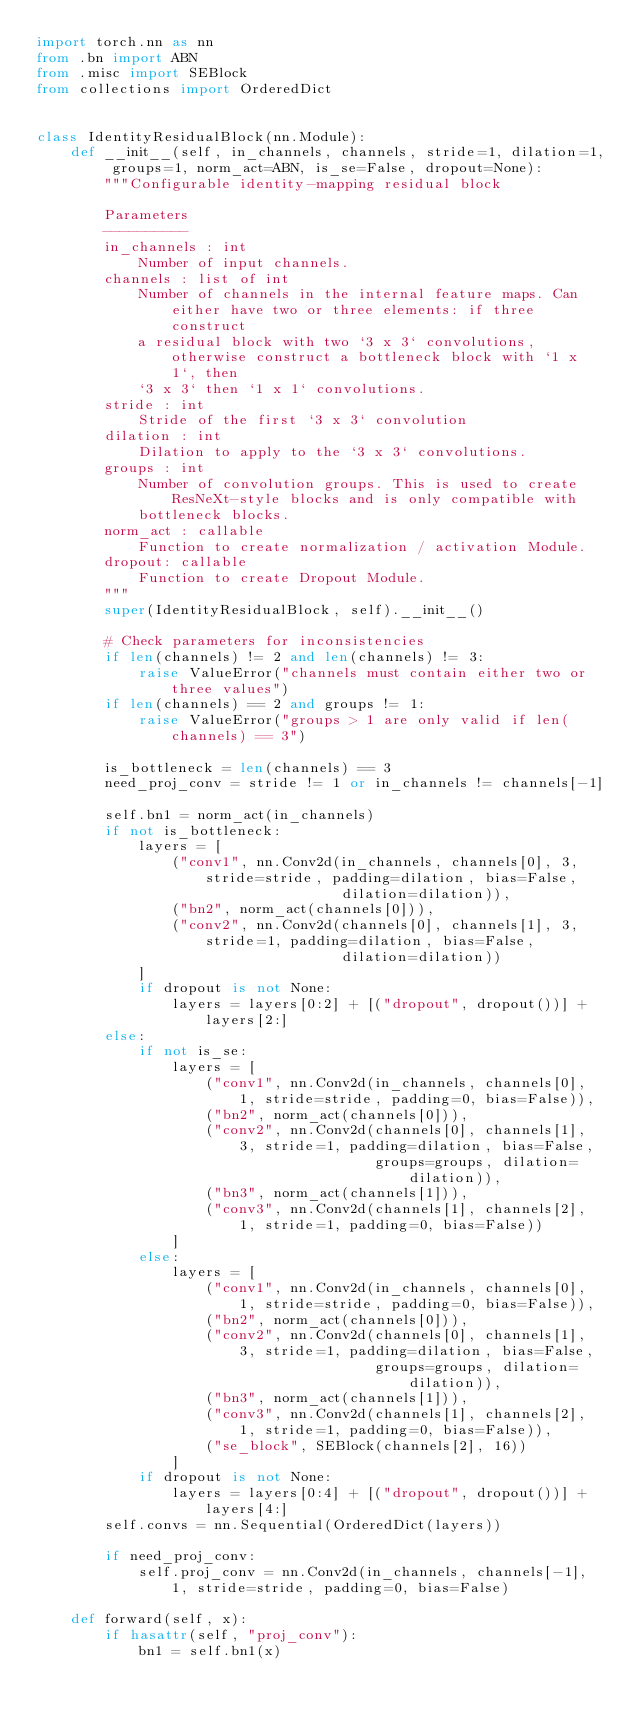Convert code to text. <code><loc_0><loc_0><loc_500><loc_500><_Python_>import torch.nn as nn
from .bn import ABN
from .misc import SEBlock
from collections import OrderedDict


class IdentityResidualBlock(nn.Module):
    def __init__(self, in_channels, channels, stride=1, dilation=1, groups=1, norm_act=ABN, is_se=False, dropout=None):
        """Configurable identity-mapping residual block

        Parameters
        ----------
        in_channels : int
            Number of input channels.
        channels : list of int
            Number of channels in the internal feature maps. Can either have two or three elements: if three construct
            a residual block with two `3 x 3` convolutions, otherwise construct a bottleneck block with `1 x 1`, then
            `3 x 3` then `1 x 1` convolutions.
        stride : int
            Stride of the first `3 x 3` convolution
        dilation : int
            Dilation to apply to the `3 x 3` convolutions.
        groups : int
            Number of convolution groups. This is used to create ResNeXt-style blocks and is only compatible with
            bottleneck blocks.
        norm_act : callable
            Function to create normalization / activation Module.
        dropout: callable
            Function to create Dropout Module.
        """
        super(IdentityResidualBlock, self).__init__()

        # Check parameters for inconsistencies
        if len(channels) != 2 and len(channels) != 3:
            raise ValueError("channels must contain either two or three values")
        if len(channels) == 2 and groups != 1:
            raise ValueError("groups > 1 are only valid if len(channels) == 3")

        is_bottleneck = len(channels) == 3
        need_proj_conv = stride != 1 or in_channels != channels[-1]

        self.bn1 = norm_act(in_channels)
        if not is_bottleneck:
            layers = [
                ("conv1", nn.Conv2d(in_channels, channels[0], 3, stride=stride, padding=dilation, bias=False,
                                    dilation=dilation)),
                ("bn2", norm_act(channels[0])),
                ("conv2", nn.Conv2d(channels[0], channels[1], 3, stride=1, padding=dilation, bias=False,
                                    dilation=dilation))
            ]
            if dropout is not None:
                layers = layers[0:2] + [("dropout", dropout())] + layers[2:]
        else:
            if not is_se:
                layers = [
                    ("conv1", nn.Conv2d(in_channels, channels[0], 1, stride=stride, padding=0, bias=False)),
                    ("bn2", norm_act(channels[0])),
                    ("conv2", nn.Conv2d(channels[0], channels[1], 3, stride=1, padding=dilation, bias=False,
                                        groups=groups, dilation=dilation)),
                    ("bn3", norm_act(channels[1])),
                    ("conv3", nn.Conv2d(channels[1], channels[2], 1, stride=1, padding=0, bias=False))
                ]
            else:
                layers = [
                    ("conv1", nn.Conv2d(in_channels, channels[0], 1, stride=stride, padding=0, bias=False)),
                    ("bn2", norm_act(channels[0])),
                    ("conv2", nn.Conv2d(channels[0], channels[1], 3, stride=1, padding=dilation, bias=False,
                                        groups=groups, dilation=dilation)),
                    ("bn3", norm_act(channels[1])),
                    ("conv3", nn.Conv2d(channels[1], channels[2], 1, stride=1, padding=0, bias=False)),
                    ("se_block", SEBlock(channels[2], 16))
                ]
            if dropout is not None:
                layers = layers[0:4] + [("dropout", dropout())] + layers[4:]
        self.convs = nn.Sequential(OrderedDict(layers))

        if need_proj_conv:
            self.proj_conv = nn.Conv2d(in_channels, channels[-1], 1, stride=stride, padding=0, bias=False)

    def forward(self, x):
        if hasattr(self, "proj_conv"):
            bn1 = self.bn1(x)</code> 